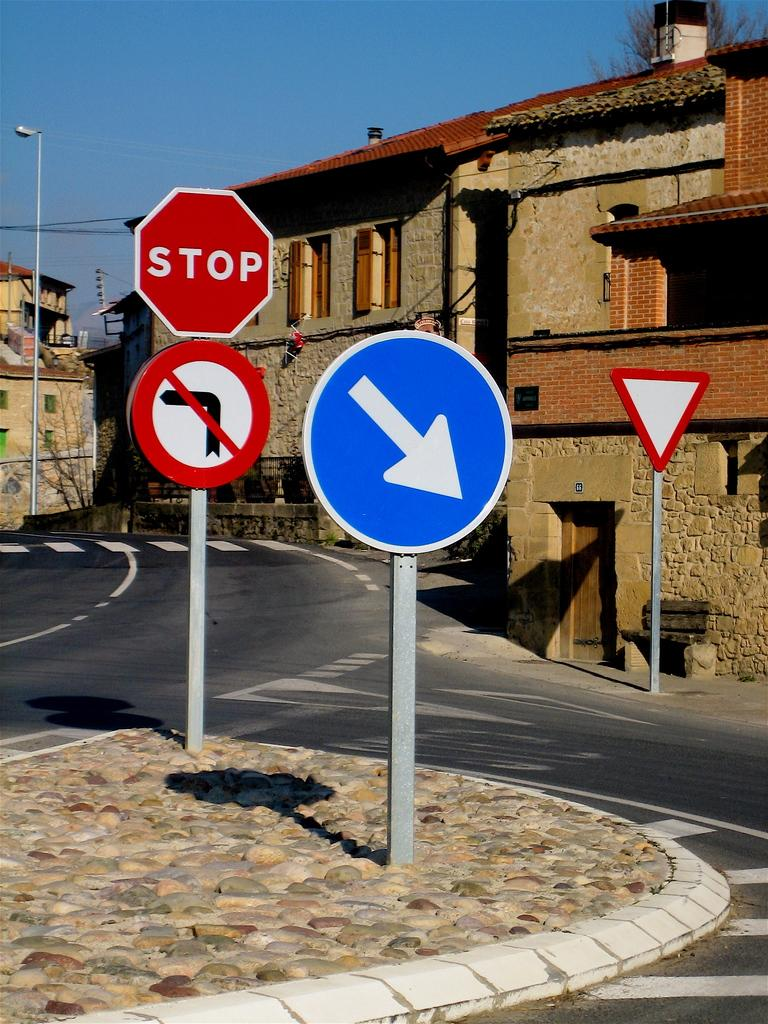What is the main feature of the image? There is a road in the image. What can be seen near the road? There are many boards and poles near the road. What is visible in the background of the image? There are buildings, trees, and a blue sky in the background of the image. What type of cactus can be seen in the image? There is no cactus present in the image. Who is the manager of the buildings in the image? The image does not provide information about the management of the buildings. 